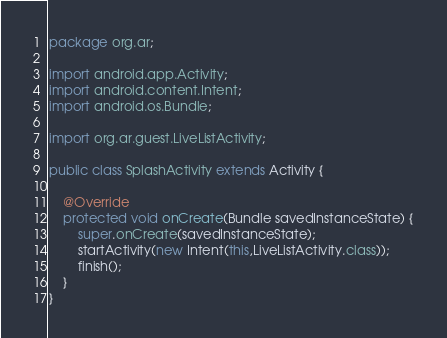<code> <loc_0><loc_0><loc_500><loc_500><_Java_>package org.ar;

import android.app.Activity;
import android.content.Intent;
import android.os.Bundle;

import org.ar.guest.LiveListActivity;

public class SplashActivity extends Activity {

    @Override
    protected void onCreate(Bundle savedInstanceState) {
        super.onCreate(savedInstanceState);
        startActivity(new Intent(this,LiveListActivity.class));
        finish();
    }
}
</code> 